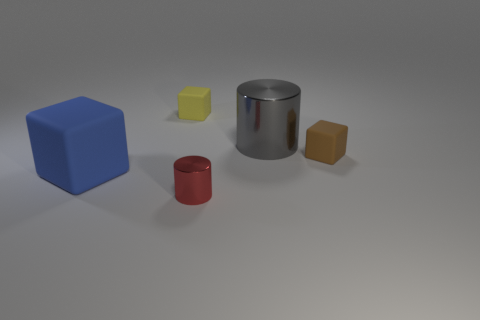Add 2 blue blocks. How many objects exist? 7 Subtract all cylinders. How many objects are left? 3 Add 1 small shiny cylinders. How many small shiny cylinders are left? 2 Add 5 red cylinders. How many red cylinders exist? 6 Subtract 1 gray cylinders. How many objects are left? 4 Subtract all small green blocks. Subtract all large gray shiny cylinders. How many objects are left? 4 